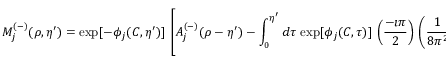Convert formula to latex. <formula><loc_0><loc_0><loc_500><loc_500>M _ { j } ^ { ( - ) } ( \rho , \eta ^ { \prime } ) = \exp [ - \phi _ { j } ( C , \eta ^ { \prime } ) ] \, \left [ A _ { j } ^ { ( - ) } ( \rho - \eta ^ { \prime } ) - \int _ { 0 } ^ { \eta ^ { \prime } } d \tau \, \exp [ \phi _ { j } ( C , \tau ) ] \, \left ( \frac { - \imath \pi } { 2 } \right ) \, \left ( \frac { 1 } { 8 \pi ^ { 2 } } \right ) \, \sum _ { j ^ { \prime } } r _ { j j ^ { \prime } } \, M _ { j ^ { \prime } } ^ { ( + ) } ( C , \tau ) \right ] .</formula> 